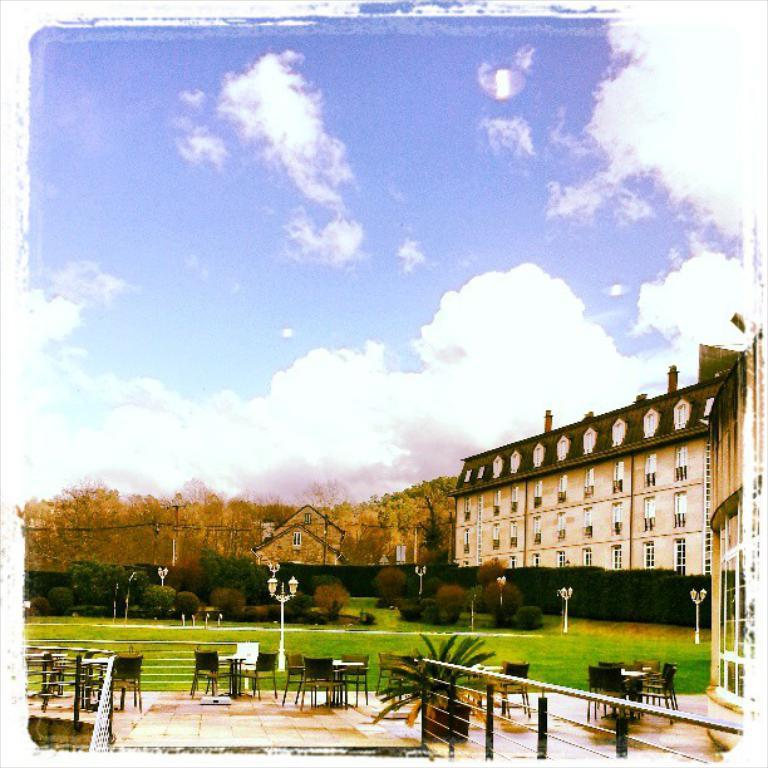What type of furniture can be seen in the image? There are chairs and tables in the image. What type of barrier is present in the image? There is a steel fence in the image. What type of vegetation is present in the image? There is grass, plants, shrubs, and trees in the image. What type of structures are present in the image? There are light poles and a house in the image. What can be seen in the background of the image? The sky is visible in the background of the image, with clouds present. How many rings are visible on the ladybug in the image? There are no ladybugs present in the image, so there are no rings to count. 